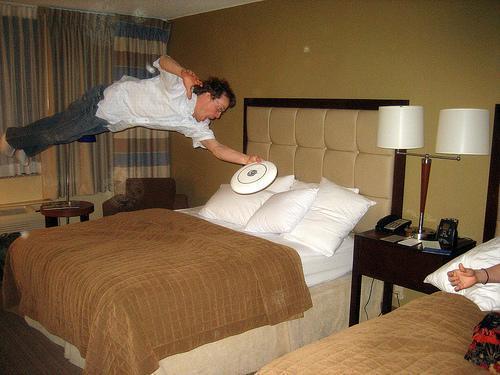How many people are in the room?
Give a very brief answer. 2. How many beds are in the photo?
Give a very brief answer. 2. How many lamps are in the photo?
Give a very brief answer. 1. How many pillows are on the bed on the left?
Give a very brief answer. 5. 